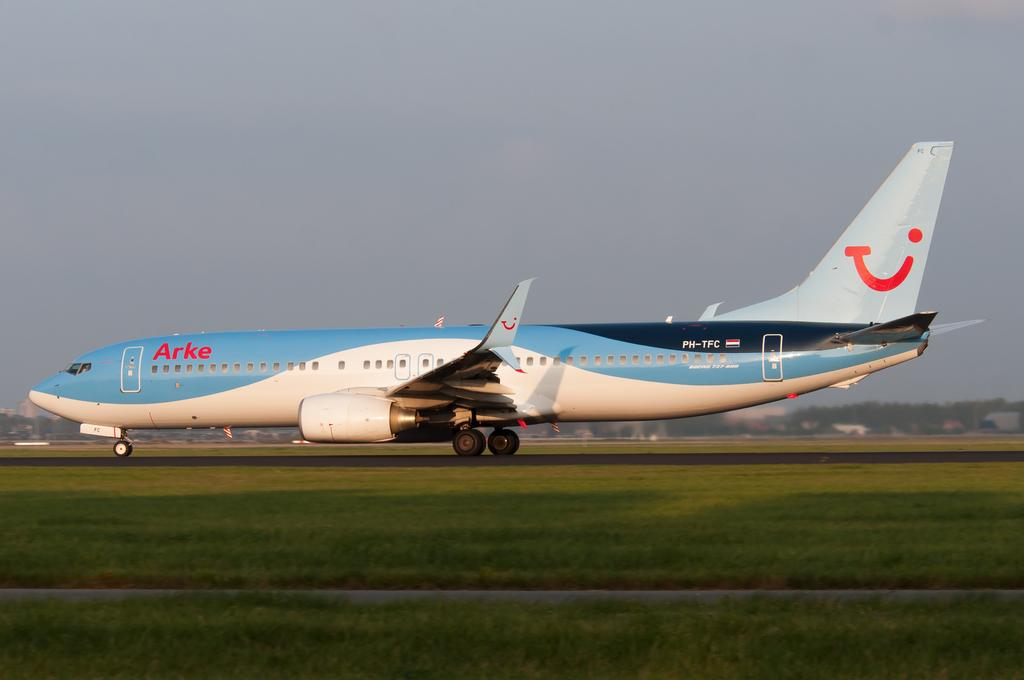<image>
Render a clear and concise summary of the photo. An Arke plane made by Boeing that is a 737-800 model. 